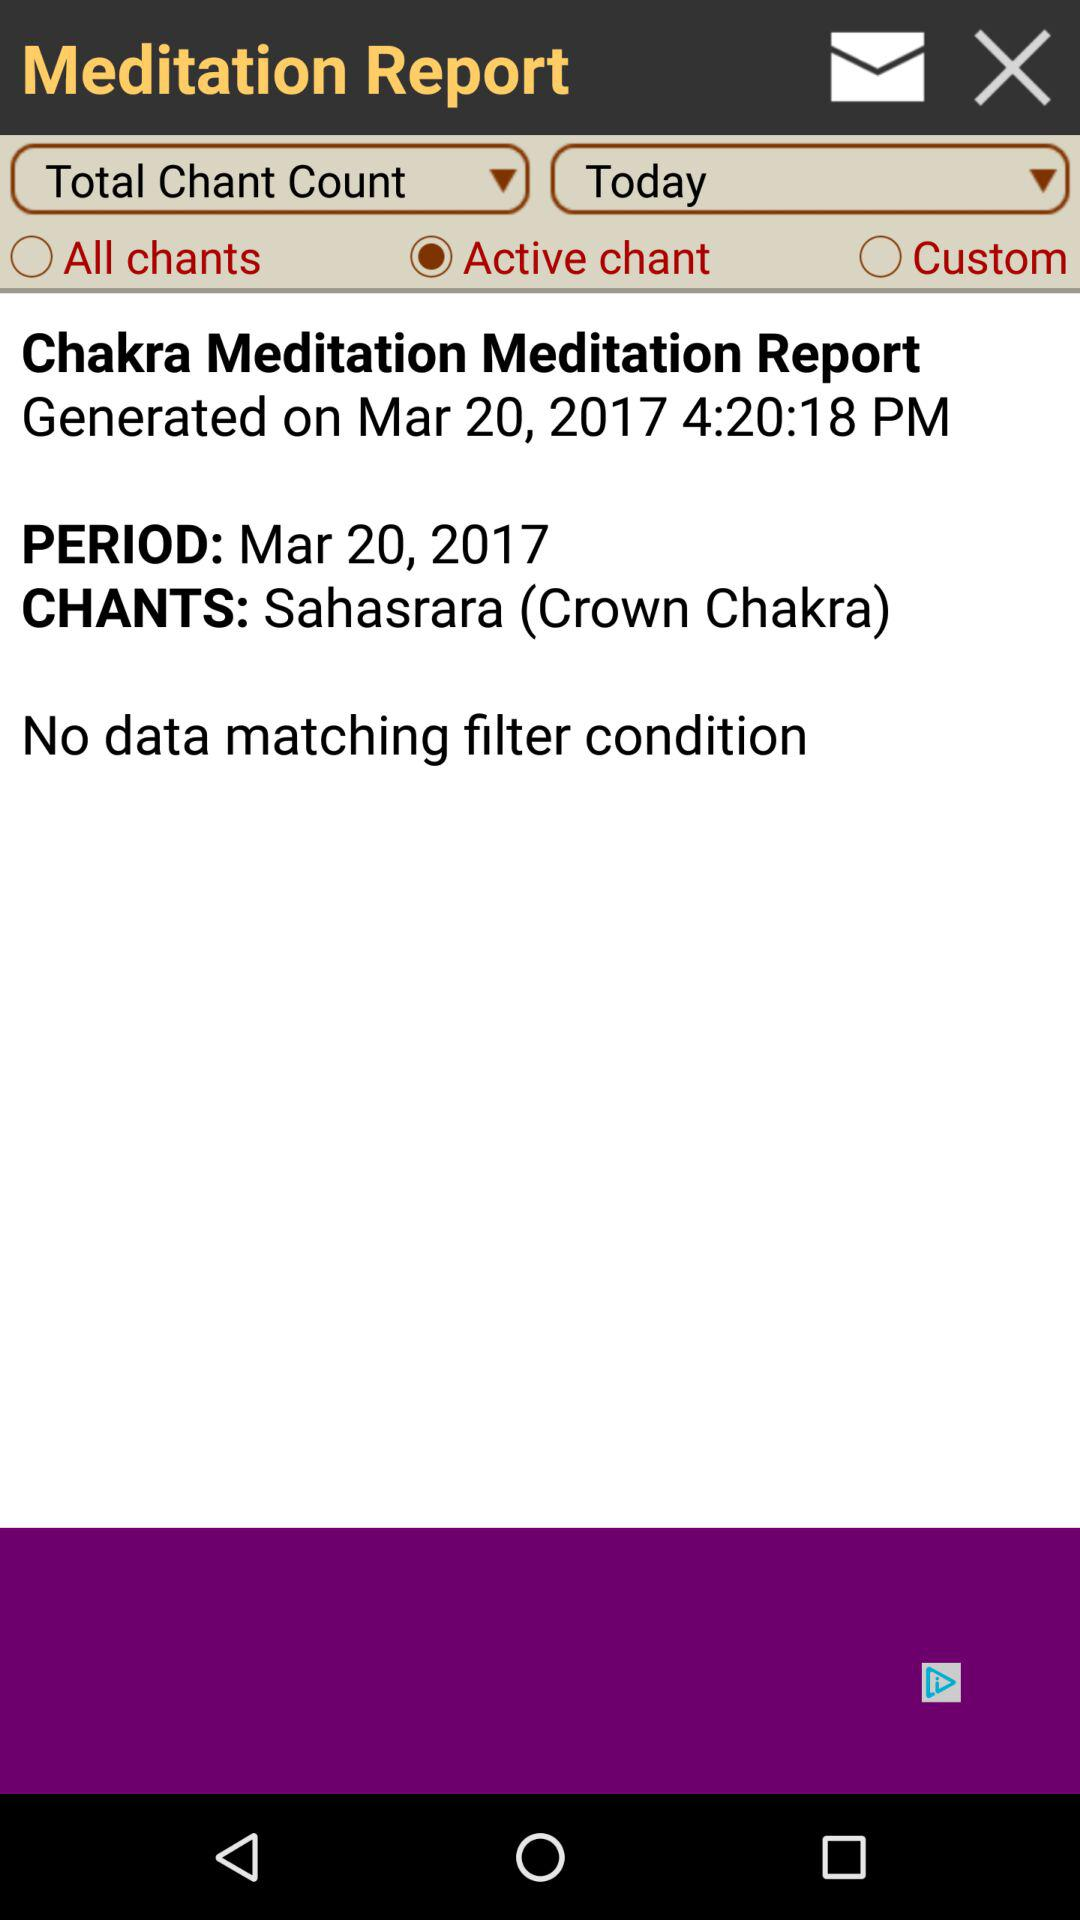What are the shown chants? The shown chants are Sahasrara (Crown Chakra). 